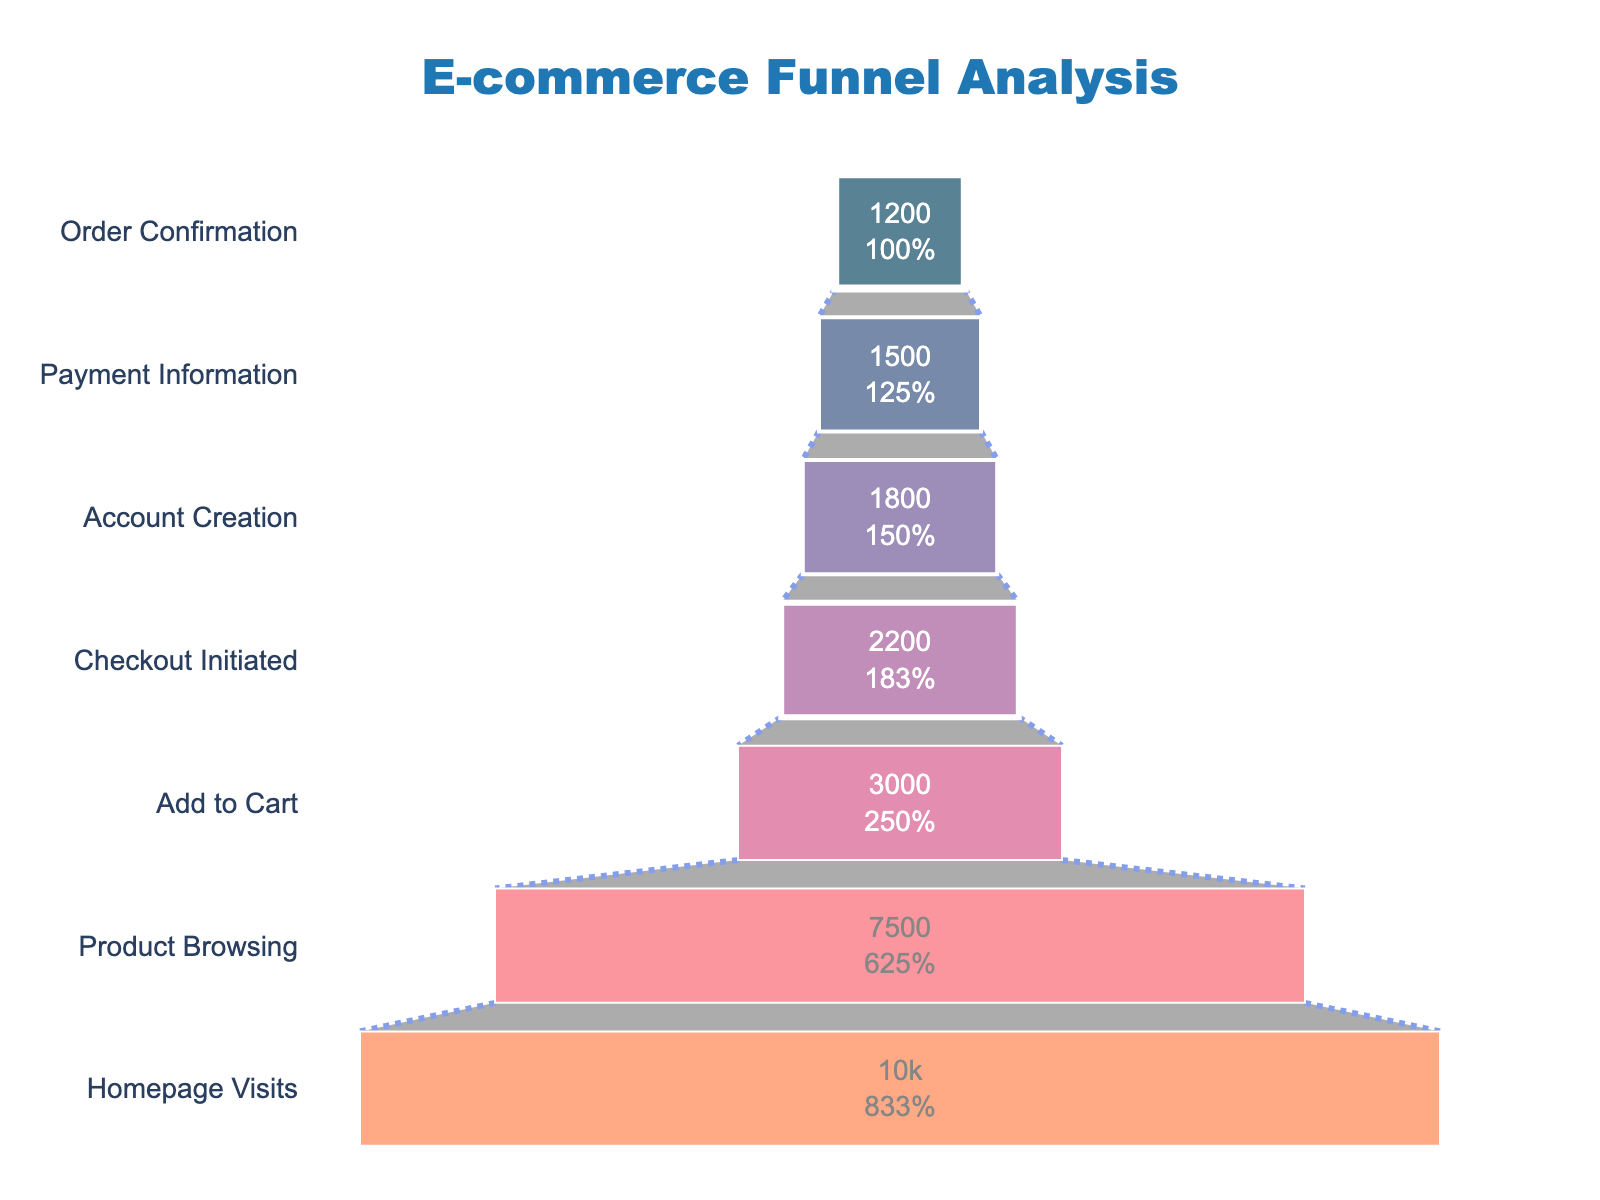How many users reached the Payment Information stage? The figure shows different stages in a funnel. The number next to "Payment Information" indicates the number of users at that stage.
Answer: 1500 What percentage of users who initiated Checkout created an account? To find this, divide the number of users who created an account (1800) by the number who initiated checkout (2200), then multiply by 100 to convert to a percentage.
Answer: 81.82% Which stage had the greatest drop in the number of users? To determine this, look at the difference in user count between consecutive stages. The largest drop is from "Product Browsing" (7500) to "Add to Cart" (3000).
Answer: Product Browsing to Add to Cart What is the title of the funnel chart? The title is usually at the top of the chart. Here, it is clearly mentioned as "E-commerce Funnel Analysis."
Answer: E-commerce Funnel Analysis How many more users added items to their cart compared to those who completed the order? Subtract the number of users who confirmed an order (1200) from those who added items to the cart (3000).
Answer: 1800 What is the purpose of the line connecting the stages in the funnel chart? The connecting line in a funnel chart typically visualizes the flow or transition of users from one stage to the next.
Answer: Visualizes the flow of users Which stage has the highest percentage drop from the initial stage? Calculate the percentage drop from the initial stage (Homepage Visits, 10000) to any subsequent stage. The largest drops can be compared. The biggest percentage drop is from Homepage Visits (10000) to Add to Cart (3000).
Answer: Add to Cart What color is used to represent the Payment Information stage? The different stages in the funnel are displayed in various colors. The Payment Information stage is shown in a shade near the end of the color spectrum for the chart, which is #f95d6a (coral).
Answer: Coral How many stages are present in the funnel chart? By counting the unique stages listed vertically in the funnel chart, you can determine the total number of stages.
Answer: 7 